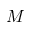<formula> <loc_0><loc_0><loc_500><loc_500>M</formula> 